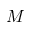<formula> <loc_0><loc_0><loc_500><loc_500>M</formula> 